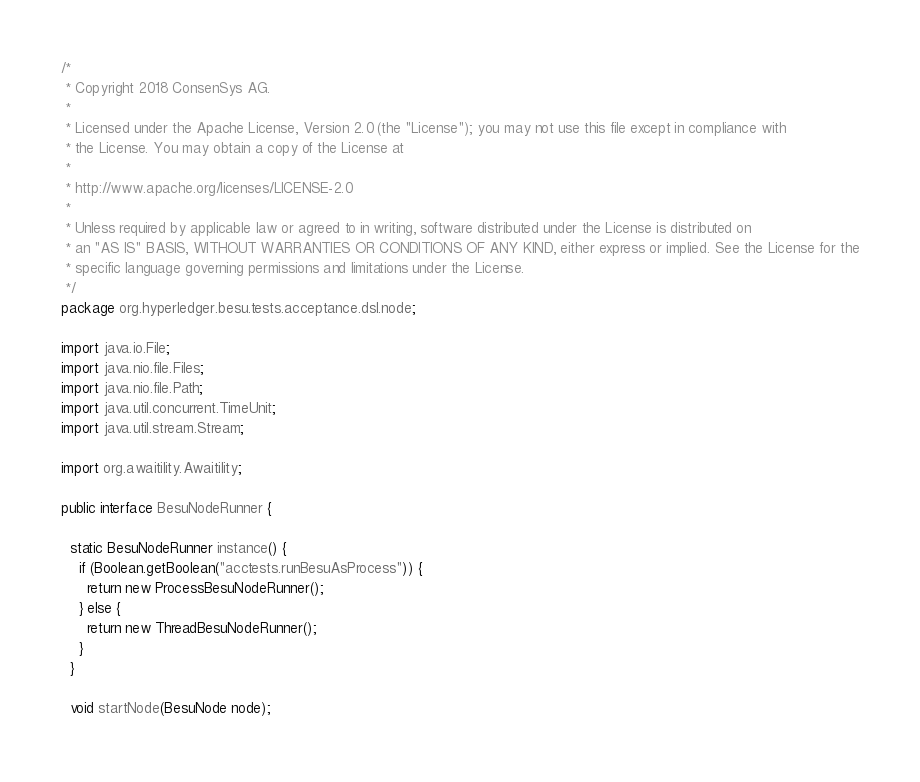<code> <loc_0><loc_0><loc_500><loc_500><_Java_>/*
 * Copyright 2018 ConsenSys AG.
 *
 * Licensed under the Apache License, Version 2.0 (the "License"); you may not use this file except in compliance with
 * the License. You may obtain a copy of the License at
 *
 * http://www.apache.org/licenses/LICENSE-2.0
 *
 * Unless required by applicable law or agreed to in writing, software distributed under the License is distributed on
 * an "AS IS" BASIS, WITHOUT WARRANTIES OR CONDITIONS OF ANY KIND, either express or implied. See the License for the
 * specific language governing permissions and limitations under the License.
 */
package org.hyperledger.besu.tests.acceptance.dsl.node;

import java.io.File;
import java.nio.file.Files;
import java.nio.file.Path;
import java.util.concurrent.TimeUnit;
import java.util.stream.Stream;

import org.awaitility.Awaitility;

public interface BesuNodeRunner {

  static BesuNodeRunner instance() {
    if (Boolean.getBoolean("acctests.runBesuAsProcess")) {
      return new ProcessBesuNodeRunner();
    } else {
      return new ThreadBesuNodeRunner();
    }
  }

  void startNode(BesuNode node);
</code> 